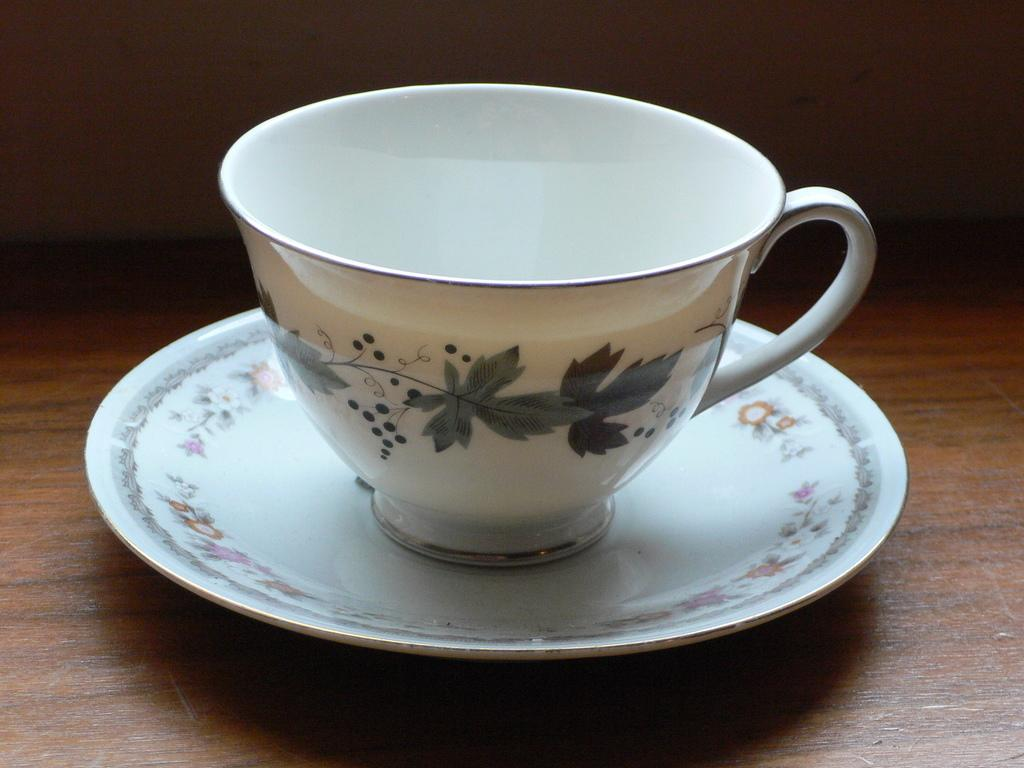What is placed on the table in the image? There is a cup and a saucer placed on a table in the image. What is the purpose of the saucer in the image? The saucer is likely used to hold the cup and catch any spills or drips. What can be seen in the background of the image? There is a wall in the background of the image. What type of credit system is being used in the image? There is no credit system present in the image; it features a cup and saucer placed on a table. What type of office furniture can be seen in the image? There is no office furniture present in the image; it features a cup and saucer placed on a table with a wall in the background. 